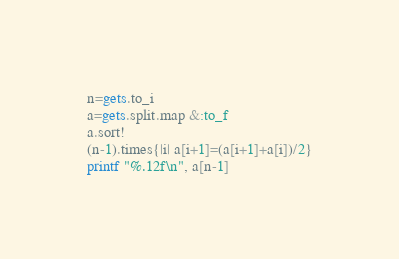<code> <loc_0><loc_0><loc_500><loc_500><_Ruby_>n=gets.to_i
a=gets.split.map &:to_f
a.sort!
(n-1).times{|i| a[i+1]=(a[i+1]+a[i])/2}
printf "%.12f\n", a[n-1]</code> 